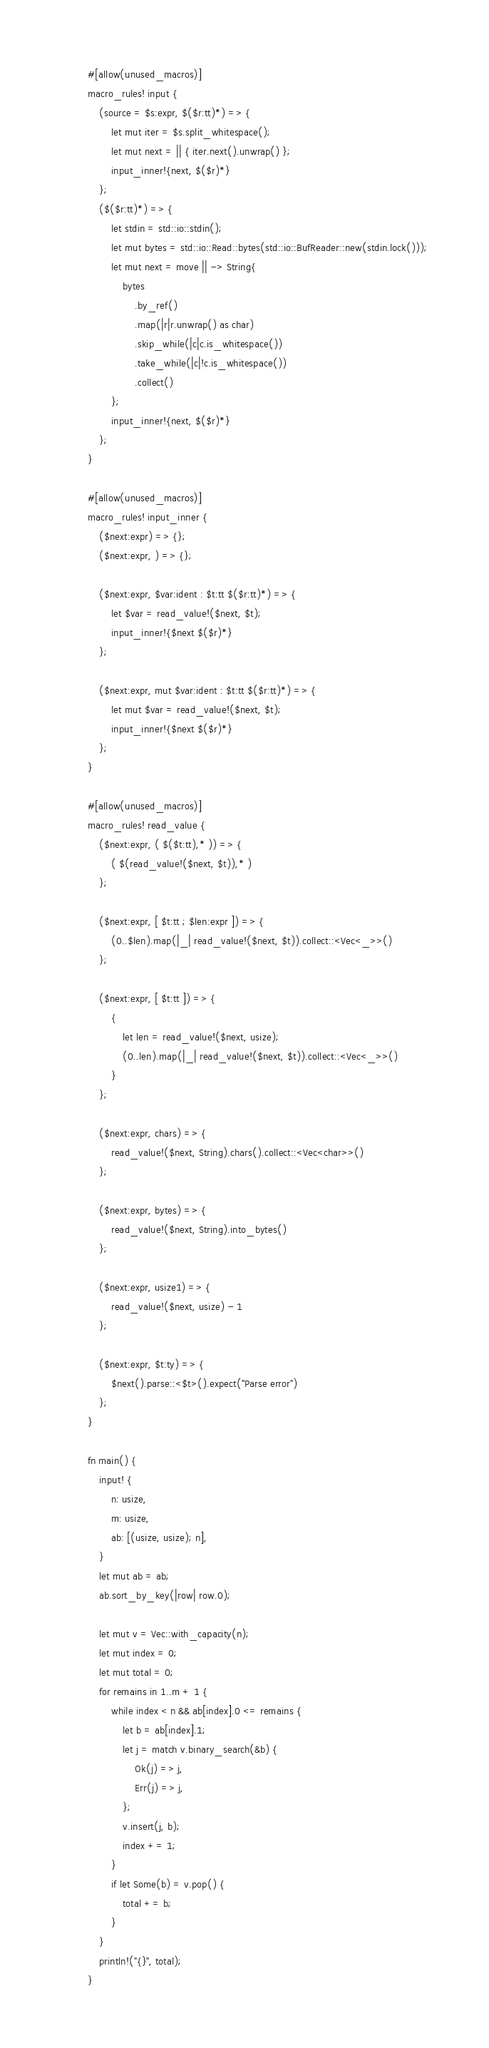<code> <loc_0><loc_0><loc_500><loc_500><_Rust_>#[allow(unused_macros)]
macro_rules! input {
    (source = $s:expr, $($r:tt)*) => {
        let mut iter = $s.split_whitespace();
        let mut next = || { iter.next().unwrap() };
        input_inner!{next, $($r)*}
    };
    ($($r:tt)*) => {
        let stdin = std::io::stdin();
        let mut bytes = std::io::Read::bytes(std::io::BufReader::new(stdin.lock()));
        let mut next = move || -> String{
            bytes
                .by_ref()
                .map(|r|r.unwrap() as char)
                .skip_while(|c|c.is_whitespace())
                .take_while(|c|!c.is_whitespace())
                .collect()
        };
        input_inner!{next, $($r)*}
    };
}

#[allow(unused_macros)]
macro_rules! input_inner {
    ($next:expr) => {};
    ($next:expr, ) => {};

    ($next:expr, $var:ident : $t:tt $($r:tt)*) => {
        let $var = read_value!($next, $t);
        input_inner!{$next $($r)*}
    };

    ($next:expr, mut $var:ident : $t:tt $($r:tt)*) => {
        let mut $var = read_value!($next, $t);
        input_inner!{$next $($r)*}
    };
}

#[allow(unused_macros)]
macro_rules! read_value {
    ($next:expr, ( $($t:tt),* )) => {
        ( $(read_value!($next, $t)),* )
    };

    ($next:expr, [ $t:tt ; $len:expr ]) => {
        (0..$len).map(|_| read_value!($next, $t)).collect::<Vec<_>>()
    };

    ($next:expr, [ $t:tt ]) => {
        {
            let len = read_value!($next, usize);
            (0..len).map(|_| read_value!($next, $t)).collect::<Vec<_>>()
        }
    };

    ($next:expr, chars) => {
        read_value!($next, String).chars().collect::<Vec<char>>()
    };

    ($next:expr, bytes) => {
        read_value!($next, String).into_bytes()
    };

    ($next:expr, usize1) => {
        read_value!($next, usize) - 1
    };

    ($next:expr, $t:ty) => {
        $next().parse::<$t>().expect("Parse error")
    };
}

fn main() {
    input! {
        n: usize,
        m: usize,
        ab: [(usize, usize); n],
    }
    let mut ab = ab;
    ab.sort_by_key(|row| row.0);

    let mut v = Vec::with_capacity(n);
    let mut index = 0;
    let mut total = 0;
    for remains in 1..m + 1 {
        while index < n && ab[index].0 <= remains {
            let b = ab[index].1;
            let j = match v.binary_search(&b) {
                Ok(j) => j,
                Err(j) => j,
            };
            v.insert(j, b);
            index += 1;
        }
        if let Some(b) = v.pop() {
            total += b;
        }
    }
    println!("{}", total);
}
</code> 